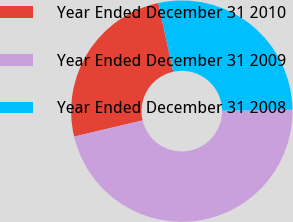Convert chart to OTSL. <chart><loc_0><loc_0><loc_500><loc_500><pie_chart><fcel>Year Ended December 31 2010<fcel>Year Ended December 31 2009<fcel>Year Ended December 31 2008<nl><fcel>25.28%<fcel>46.5%<fcel>28.22%<nl></chart> 